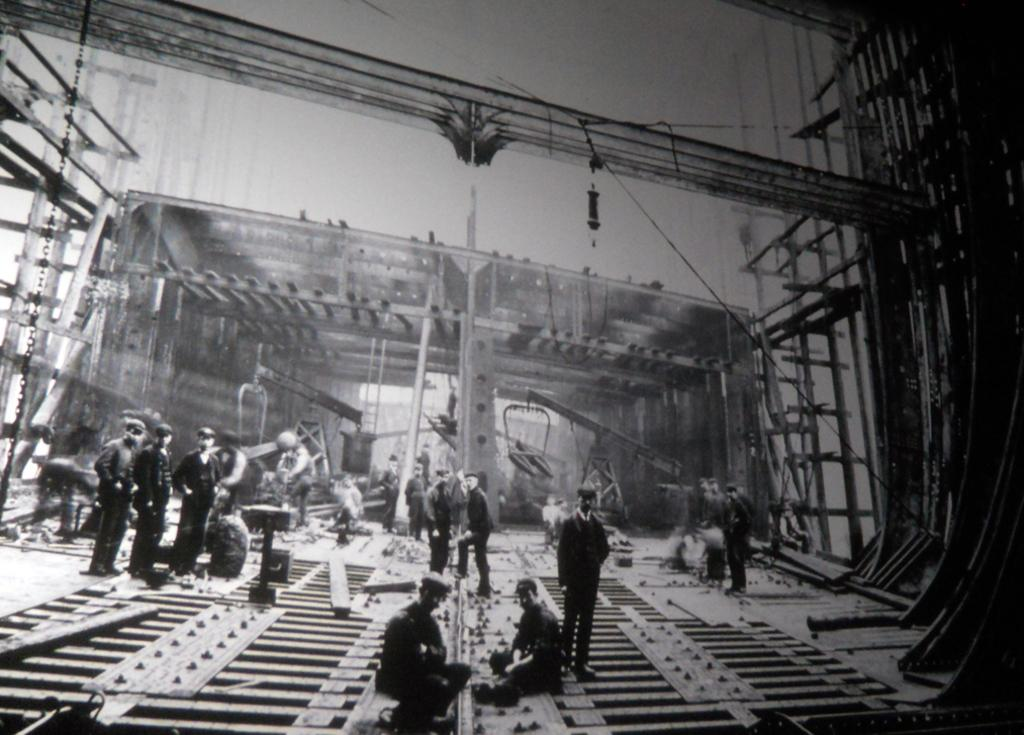What is the color scheme of the image? The image is black and white. Can you describe the age of the image? The image is old. What are the workers in the image doing? The workers are constructing a railway track. What type of land can be seen in the background of the image? There is no specific type of land mentioned or visible in the image, as it is black and white and focuses on the workers constructing a railway track. Is there a volleyball game happening in the image? No, there is no volleyball game or any reference to a volleyball game in the image. 